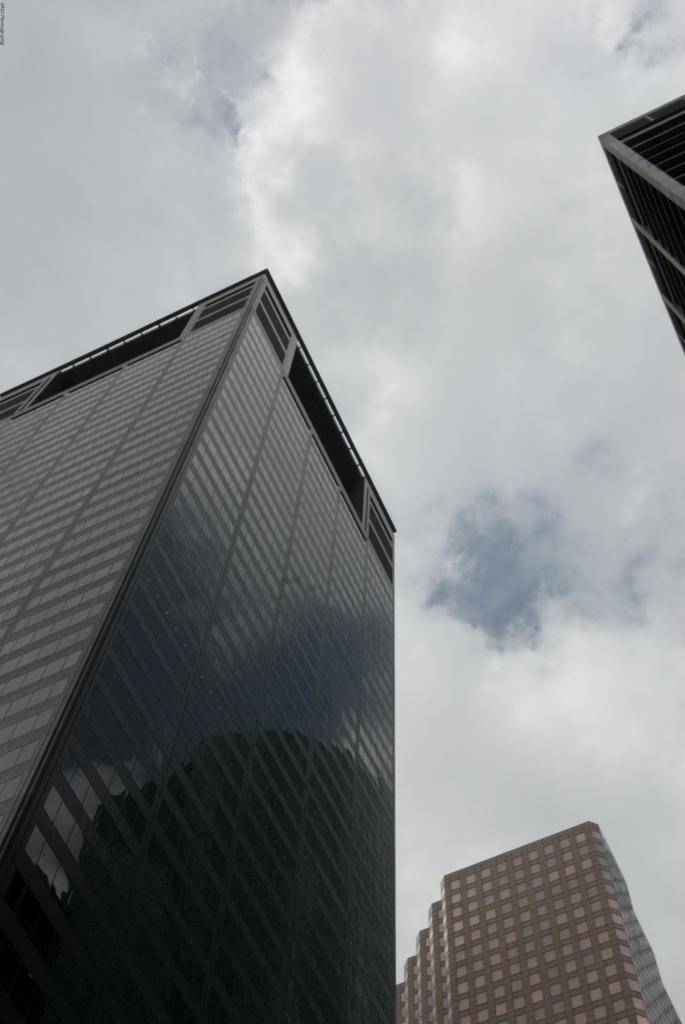What type of structures are present in the image? There are buildings in the image. What feature can be observed on the buildings? The buildings have glass windows. What is the condition of the sky in the image? The sky is cloudy in the image. What type of pump can be seen near the buildings in the image? There is no pump present in the image; it only features buildings with glass windows and a cloudy sky. What reward is being given to the table in the image? There is no table or reward present in the image. 